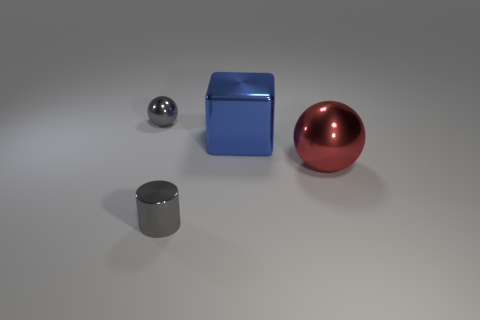Are there any things in front of the big red ball?
Offer a very short reply. Yes. Are there more metal cylinders than green rubber cylinders?
Your answer should be compact. Yes. What is the color of the sphere to the right of the gray thing behind the tiny gray object that is on the right side of the small shiny sphere?
Keep it short and to the point. Red. What color is the small cylinder that is made of the same material as the small sphere?
Your answer should be very brief. Gray. What number of things are either metallic balls on the left side of the tiny gray cylinder or metal spheres in front of the big blue object?
Give a very brief answer. 2. There is a gray thing in front of the gray sphere; is its size the same as the sphere that is right of the small sphere?
Offer a very short reply. No. Are there any other things that have the same shape as the red thing?
Offer a terse response. Yes. Is the number of gray shiny cylinders on the right side of the small gray ball greater than the number of red things that are behind the red shiny ball?
Your answer should be very brief. Yes. How big is the gray object that is on the left side of the tiny metallic object that is in front of the red thing to the right of the blue metallic block?
Offer a terse response. Small. Is the blue object made of the same material as the gray thing that is in front of the blue thing?
Your response must be concise. Yes. 